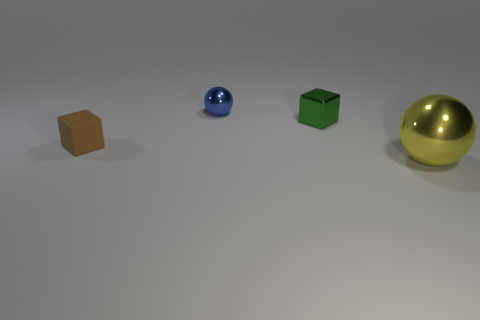Add 3 blue shiny spheres. How many objects exist? 7 Add 2 tiny blue objects. How many tiny blue objects exist? 3 Subtract 0 yellow cubes. How many objects are left? 4 Subtract all big purple cylinders. Subtract all matte objects. How many objects are left? 3 Add 1 metallic things. How many metallic things are left? 4 